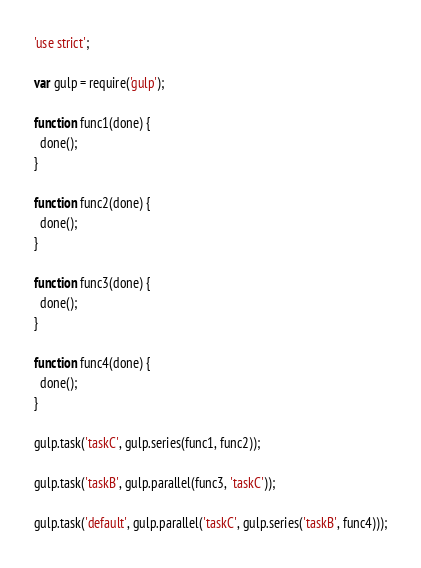Convert code to text. <code><loc_0><loc_0><loc_500><loc_500><_JavaScript_>'use strict';

var gulp = require('gulp');

function func1(done) {
  done();
}

function func2(done) {
  done();
}

function func3(done) {
  done();
}

function func4(done) {
  done();
}

gulp.task('taskC', gulp.series(func1, func2));

gulp.task('taskB', gulp.parallel(func3, 'taskC'));

gulp.task('default', gulp.parallel('taskC', gulp.series('taskB', func4)));

</code> 